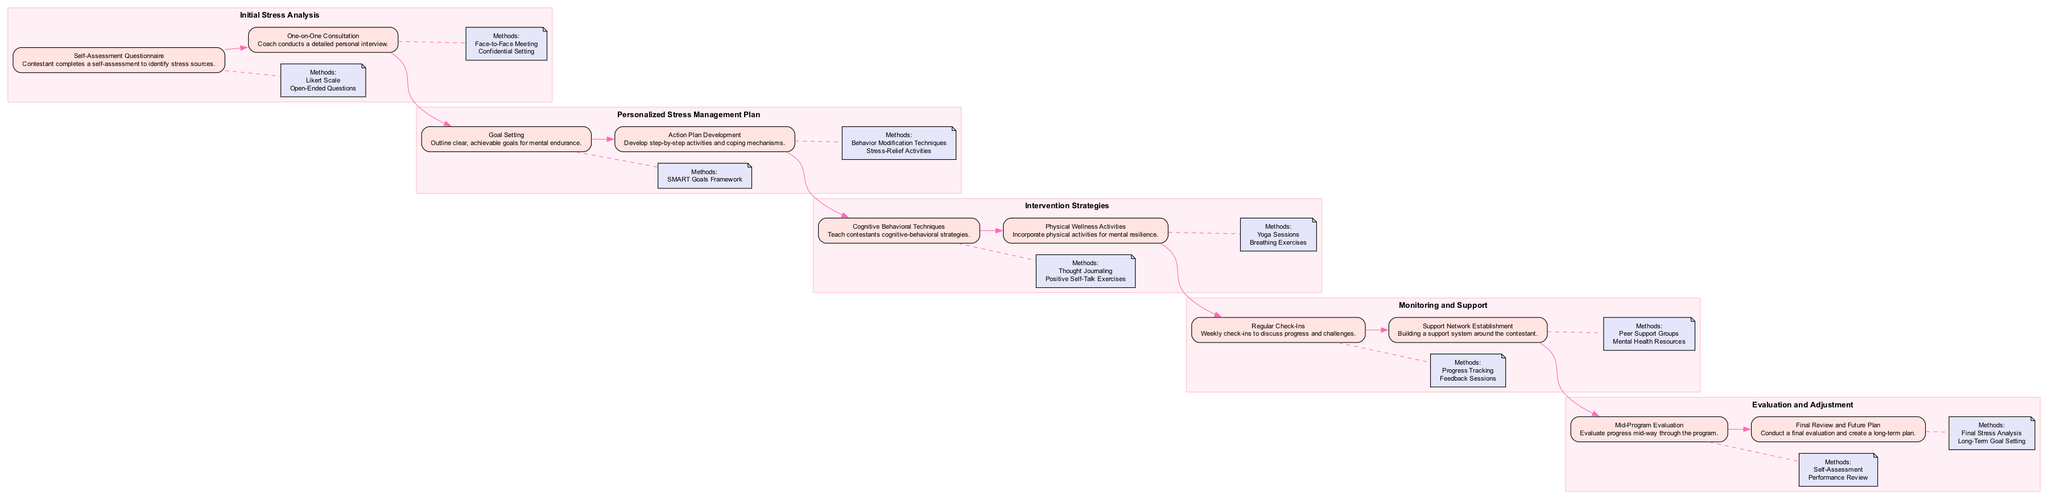What is the first step in the Initial Stress Analysis? The first step in the Initial Stress Analysis is "Self-Assessment Questionnaire". It is explicitly stated within the stage labeled "Initial Stress Analysis" in the diagram.
Answer: Self-Assessment Questionnaire How many strategies are listed in the Intervention Strategies? In the Intervention Strategies stage, there are two strategies outlined: "Cognitive Behavioral Techniques" and "Physical Wellness Activities". This can be counted directly in the diagram.
Answer: 2 What method is used for Mid-Program Evaluation? The method used for Mid-Program Evaluation is "Self-Assessment". This is mentioned in the last stage, Evaluation and Adjustment, under the corresponding step.
Answer: Self-Assessment What is the purpose of Regular Check-Ins? The purpose of Regular Check-Ins is to discuss "progress and challenges", as detailed in the Monitoring and Support stage. This explains the intent behind this step in the pathway.
Answer: progress and challenges Name a method used in Action Plan Development. One of the methods used in Action Plan Development is "Behavior Modification Techniques", which is specified as part of the step in the Personalized Stress Management Plan stage.
Answer: Behavior Modification Techniques How many main stages are in the Clinical Pathway? There are five main stages in the Clinical Pathway: Initial Stress Analysis, Personalized Stress Management Plan, Intervention Strategies, Monitoring and Support, and Evaluation and Adjustment. This can be counted from the diagram.
Answer: 5 Which step comes after Goal Setting? The step that comes after Goal Setting in the Personalized Stress Management Plan stage is "Action Plan Development". This order can be traced directly in the sequence of steps in the pathway.
Answer: Action Plan Development What is the last method mentioned in the Evaluation and Adjustment stage? The last method mentioned in the Evaluation and Adjustment stage is "Long-Term Goal Setting", according to the last step described in that stage.
Answer: Long-Term Goal Setting What is an example of a method in the Support Network Establishment step? An example of a method used in the Support Network Establishment step is "Peer Support Groups", which is directly listed under that step in the diagram.
Answer: Peer Support Groups 